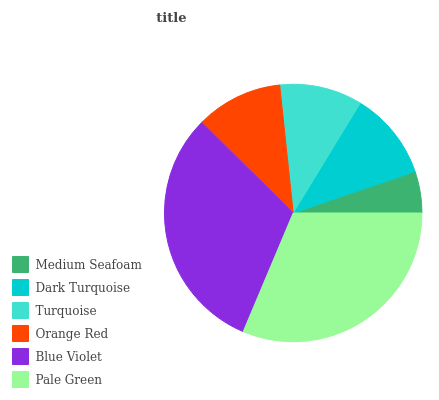Is Medium Seafoam the minimum?
Answer yes or no. Yes. Is Pale Green the maximum?
Answer yes or no. Yes. Is Dark Turquoise the minimum?
Answer yes or no. No. Is Dark Turquoise the maximum?
Answer yes or no. No. Is Dark Turquoise greater than Medium Seafoam?
Answer yes or no. Yes. Is Medium Seafoam less than Dark Turquoise?
Answer yes or no. Yes. Is Medium Seafoam greater than Dark Turquoise?
Answer yes or no. No. Is Dark Turquoise less than Medium Seafoam?
Answer yes or no. No. Is Dark Turquoise the high median?
Answer yes or no. Yes. Is Orange Red the low median?
Answer yes or no. Yes. Is Turquoise the high median?
Answer yes or no. No. Is Pale Green the low median?
Answer yes or no. No. 